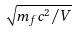Convert formula to latex. <formula><loc_0><loc_0><loc_500><loc_500>\sqrt { m _ { f } c ^ { 2 } / V }</formula> 